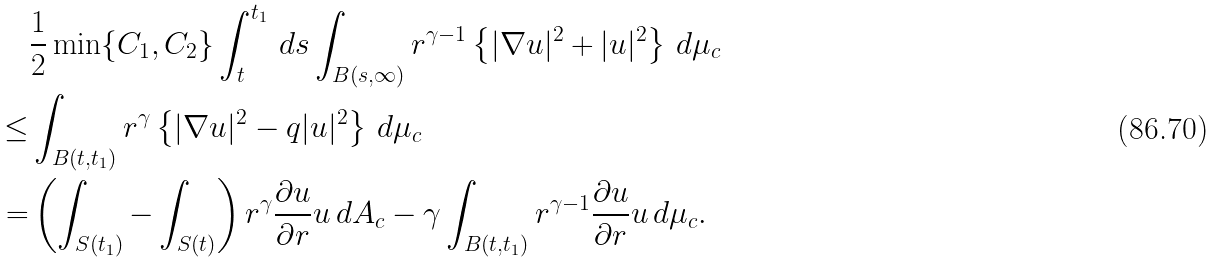Convert formula to latex. <formula><loc_0><loc_0><loc_500><loc_500>& \frac { 1 } { 2 } \min \{ C _ { 1 } , C _ { 2 } \} \int ^ { t _ { 1 } } _ { t } \, d s \int _ { B ( s , \infty ) } r ^ { \gamma - 1 } \left \{ | \nabla u | ^ { 2 } + | u | ^ { 2 } \right \} \, d \mu _ { c } \\ \leq & \int _ { B ( t , t _ { 1 } ) } r ^ { \gamma } \left \{ | \nabla u | ^ { 2 } - q | u | ^ { 2 } \right \} \, d \mu _ { c } \\ = & \left ( \int _ { S ( t _ { 1 } ) } - \int _ { S ( t ) } \right ) r ^ { \gamma } \frac { \partial u } { \partial r } u \, d A _ { c } - \gamma \int _ { B ( t , t _ { 1 } ) } r ^ { \gamma - 1 } \frac { \partial u } { \partial r } u \, d \mu _ { c } .</formula> 